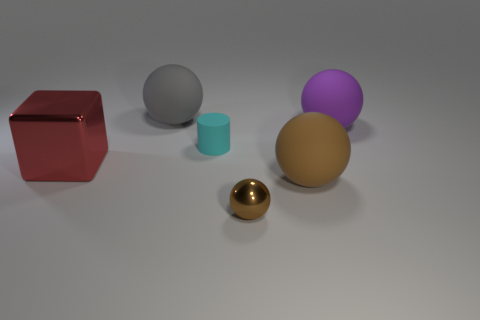Subtract all large gray spheres. How many spheres are left? 3 Add 2 gray objects. How many objects exist? 8 Subtract all brown blocks. How many brown balls are left? 2 Subtract 1 spheres. How many spheres are left? 3 Subtract all purple balls. How many balls are left? 3 Subtract all cylinders. How many objects are left? 5 Subtract all purple balls. Subtract all red cylinders. How many balls are left? 3 Subtract 0 purple cylinders. How many objects are left? 6 Subtract all small cyan things. Subtract all brown shiny balls. How many objects are left? 4 Add 4 large brown rubber spheres. How many large brown rubber spheres are left? 5 